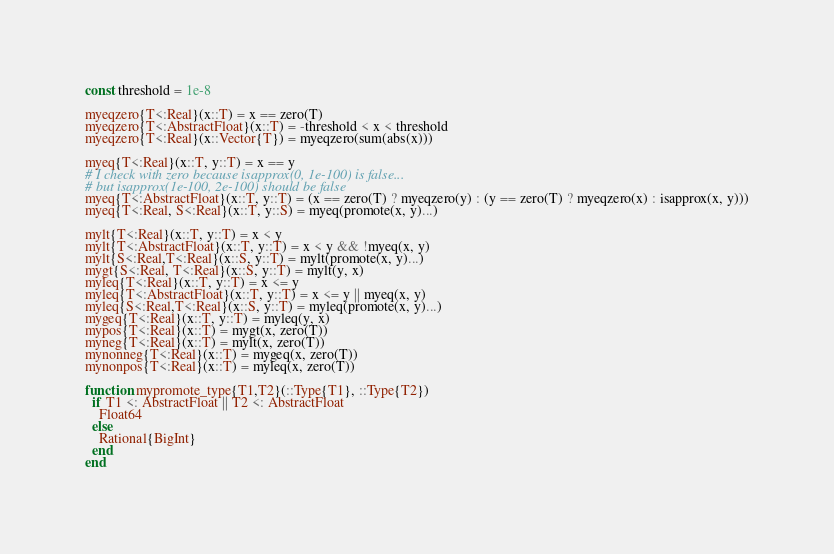<code> <loc_0><loc_0><loc_500><loc_500><_Julia_>const threshold = 1e-8

myeqzero{T<:Real}(x::T) = x == zero(T)
myeqzero{T<:AbstractFloat}(x::T) = -threshold < x < threshold
myeqzero{T<:Real}(x::Vector{T}) = myeqzero(sum(abs(x)))

myeq{T<:Real}(x::T, y::T) = x == y
# I check with zero because isapprox(0, 1e-100) is false...
# but isapprox(1e-100, 2e-100) should be false
myeq{T<:AbstractFloat}(x::T, y::T) = (x == zero(T) ? myeqzero(y) : (y == zero(T) ? myeqzero(x) : isapprox(x, y)))
myeq{T<:Real, S<:Real}(x::T, y::S) = myeq(promote(x, y)...)

mylt{T<:Real}(x::T, y::T) = x < y
mylt{T<:AbstractFloat}(x::T, y::T) = x < y && !myeq(x, y)
mylt{S<:Real,T<:Real}(x::S, y::T) = mylt(promote(x, y)...)
mygt{S<:Real, T<:Real}(x::S, y::T) = mylt(y, x)
myleq{T<:Real}(x::T, y::T) = x <= y
myleq{T<:AbstractFloat}(x::T, y::T) = x <= y || myeq(x, y)
myleq{S<:Real,T<:Real}(x::S, y::T) = myleq(promote(x, y)...)
mygeq{T<:Real}(x::T, y::T) = myleq(y, x)
mypos{T<:Real}(x::T) = mygt(x, zero(T))
myneg{T<:Real}(x::T) = mylt(x, zero(T))
mynonneg{T<:Real}(x::T) = mygeq(x, zero(T))
mynonpos{T<:Real}(x::T) = myleq(x, zero(T))

function mypromote_type{T1,T2}(::Type{T1}, ::Type{T2})
  if T1 <: AbstractFloat || T2 <: AbstractFloat
    Float64
  else
    Rational{BigInt}
  end
end
</code> 